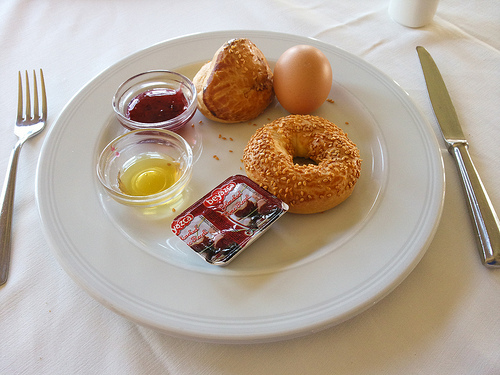<image>
Can you confirm if the knife is next to the egg? Yes. The knife is positioned adjacent to the egg, located nearby in the same general area. Where is the plate in relation to the knife? Is it in front of the knife? No. The plate is not in front of the knife. The spatial positioning shows a different relationship between these objects. 